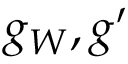Convert formula to latex. <formula><loc_0><loc_0><loc_500><loc_500>g _ { W } , g ^ { \prime }</formula> 